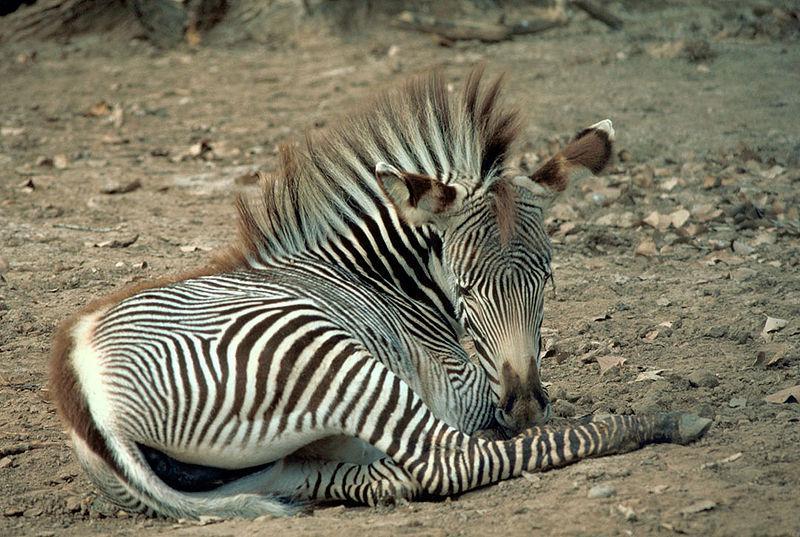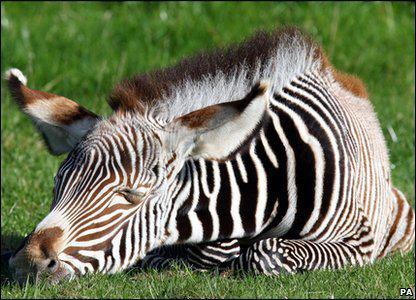The first image is the image on the left, the second image is the image on the right. Evaluate the accuracy of this statement regarding the images: "One image includes a zebra lying flat on its side with its head also flat on the brown ground.". Is it true? Answer yes or no. No. The first image is the image on the left, the second image is the image on the right. For the images shown, is this caption "There are two zebras" true? Answer yes or no. Yes. 